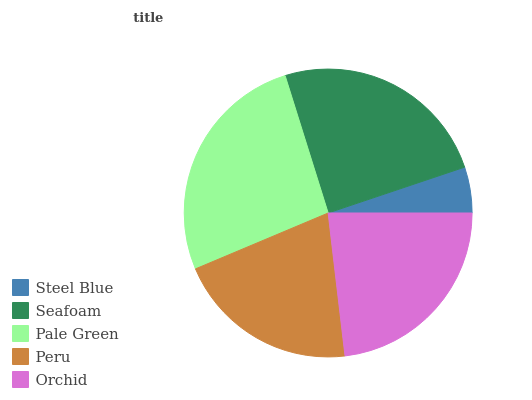Is Steel Blue the minimum?
Answer yes or no. Yes. Is Pale Green the maximum?
Answer yes or no. Yes. Is Seafoam the minimum?
Answer yes or no. No. Is Seafoam the maximum?
Answer yes or no. No. Is Seafoam greater than Steel Blue?
Answer yes or no. Yes. Is Steel Blue less than Seafoam?
Answer yes or no. Yes. Is Steel Blue greater than Seafoam?
Answer yes or no. No. Is Seafoam less than Steel Blue?
Answer yes or no. No. Is Orchid the high median?
Answer yes or no. Yes. Is Orchid the low median?
Answer yes or no. Yes. Is Pale Green the high median?
Answer yes or no. No. Is Peru the low median?
Answer yes or no. No. 